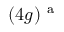Convert formula to latex. <formula><loc_0><loc_0><loc_500><loc_500>( 4 g ) ^ { a }</formula> 